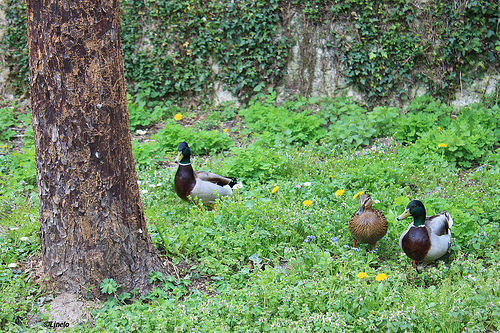<image>
Can you confirm if the duck is on the grass? Yes. Looking at the image, I can see the duck is positioned on top of the grass, with the grass providing support. Is there a duck next to the tree? Yes. The duck is positioned adjacent to the tree, located nearby in the same general area. 